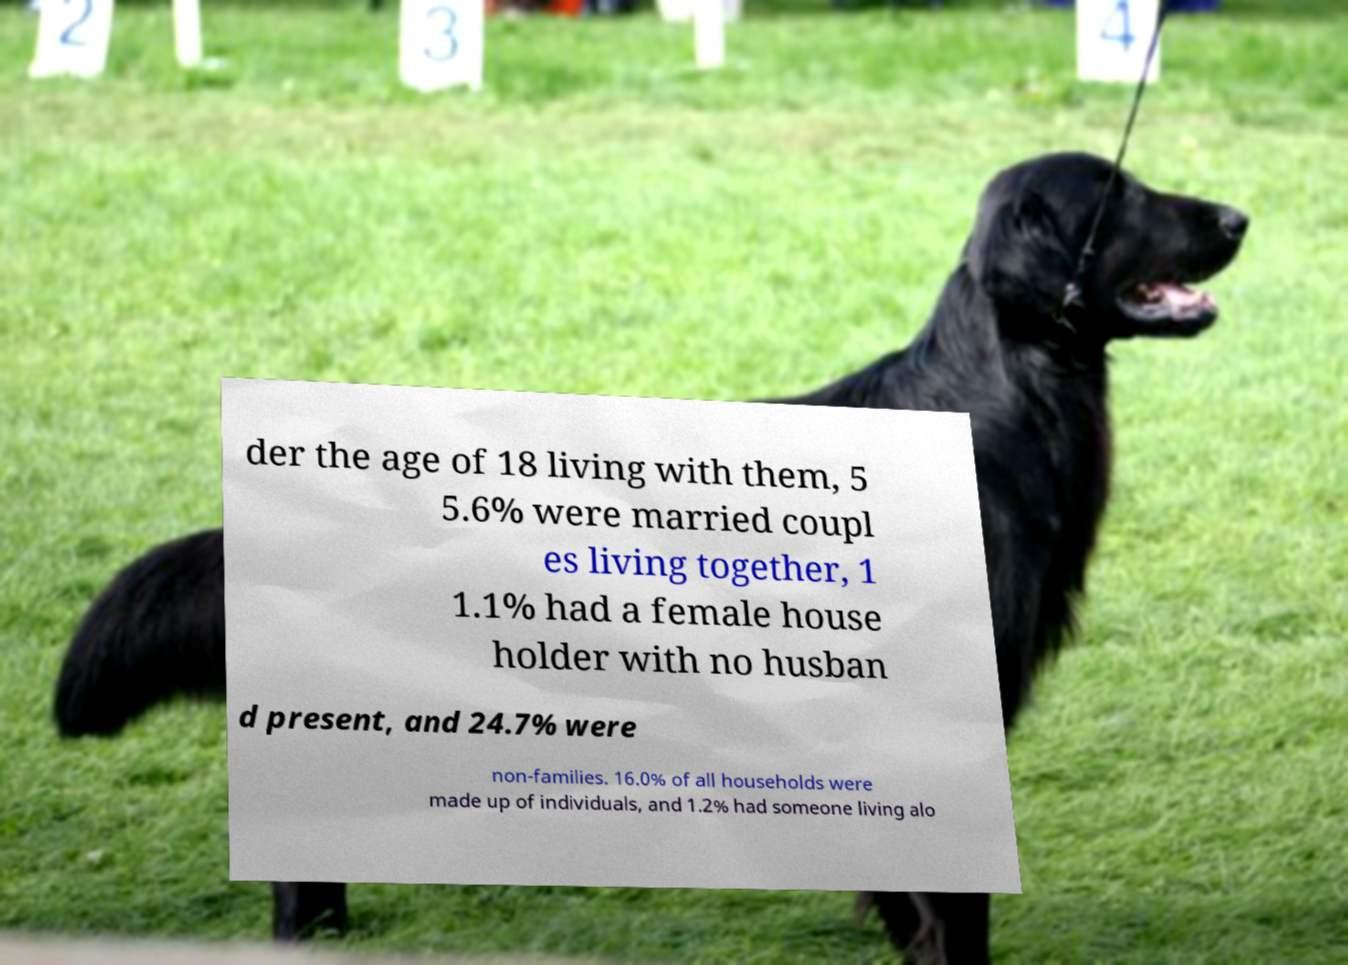What messages or text are displayed in this image? I need them in a readable, typed format. der the age of 18 living with them, 5 5.6% were married coupl es living together, 1 1.1% had a female house holder with no husban d present, and 24.7% were non-families. 16.0% of all households were made up of individuals, and 1.2% had someone living alo 